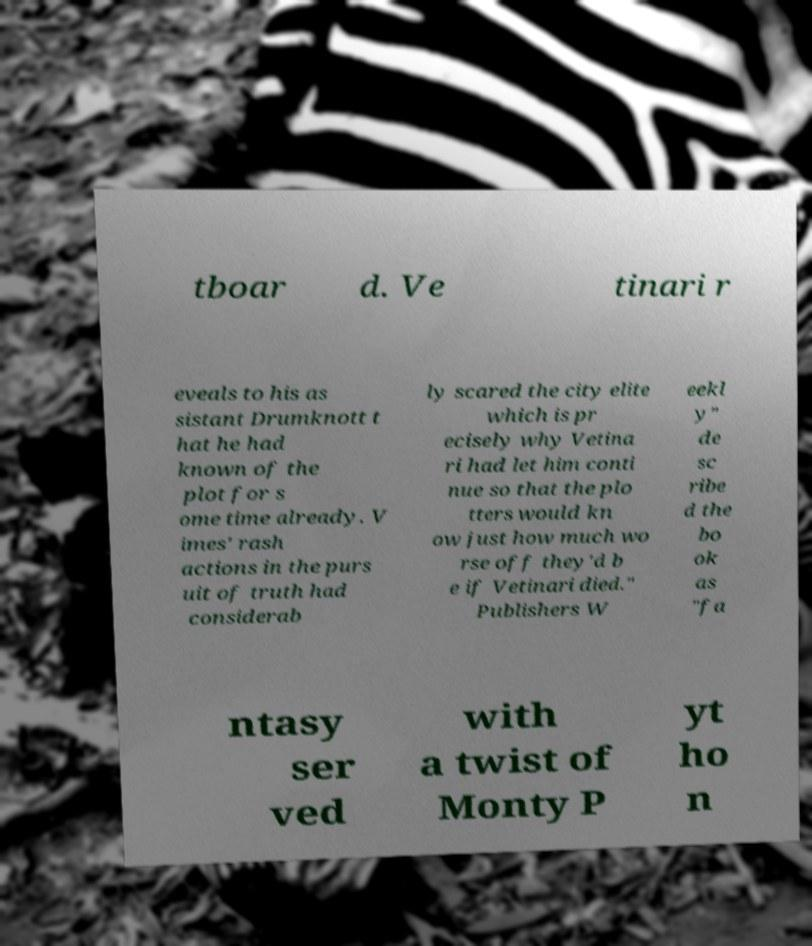There's text embedded in this image that I need extracted. Can you transcribe it verbatim? tboar d. Ve tinari r eveals to his as sistant Drumknott t hat he had known of the plot for s ome time already. V imes' rash actions in the purs uit of truth had considerab ly scared the city elite which is pr ecisely why Vetina ri had let him conti nue so that the plo tters would kn ow just how much wo rse off they'd b e if Vetinari died." Publishers W eekl y" de sc ribe d the bo ok as "fa ntasy ser ved with a twist of Monty P yt ho n 